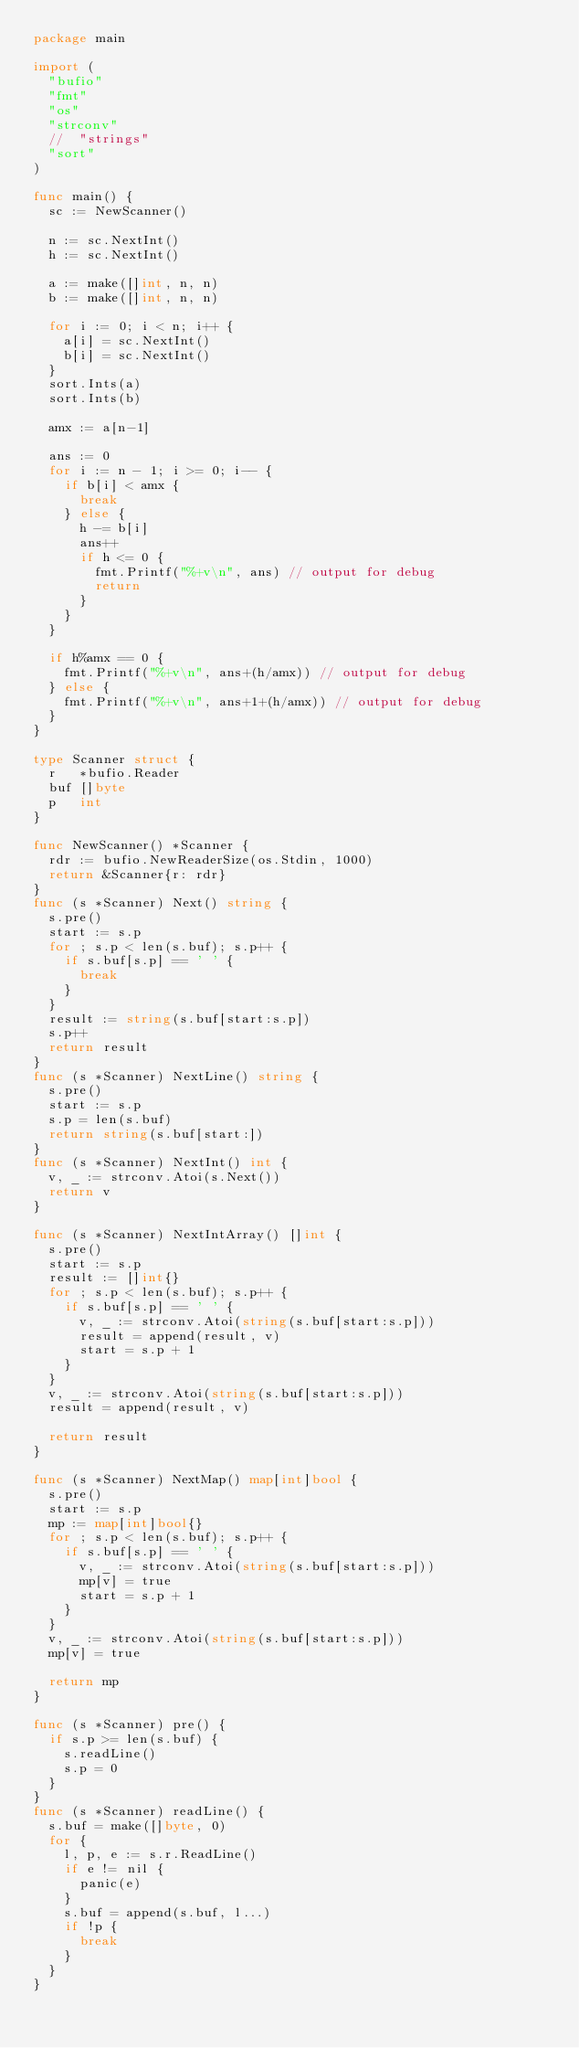Convert code to text. <code><loc_0><loc_0><loc_500><loc_500><_Go_>package main

import (
	"bufio"
	"fmt"
	"os"
	"strconv"
	//	"strings"
	"sort"
)

func main() {
	sc := NewScanner()

	n := sc.NextInt()
	h := sc.NextInt()

	a := make([]int, n, n)
	b := make([]int, n, n)

	for i := 0; i < n; i++ {
		a[i] = sc.NextInt()
		b[i] = sc.NextInt()
	}
	sort.Ints(a)
	sort.Ints(b)

	amx := a[n-1]

	ans := 0
	for i := n - 1; i >= 0; i-- {
		if b[i] < amx {
			break
		} else {
			h -= b[i]
			ans++
			if h <= 0 {
				fmt.Printf("%+v\n", ans) // output for debug
				return
			}
		}
	}

	if h%amx == 0 {
		fmt.Printf("%+v\n", ans+(h/amx)) // output for debug
	} else {
		fmt.Printf("%+v\n", ans+1+(h/amx)) // output for debug
	}
}

type Scanner struct {
	r   *bufio.Reader
	buf []byte
	p   int
}

func NewScanner() *Scanner {
	rdr := bufio.NewReaderSize(os.Stdin, 1000)
	return &Scanner{r: rdr}
}
func (s *Scanner) Next() string {
	s.pre()
	start := s.p
	for ; s.p < len(s.buf); s.p++ {
		if s.buf[s.p] == ' ' {
			break
		}
	}
	result := string(s.buf[start:s.p])
	s.p++
	return result
}
func (s *Scanner) NextLine() string {
	s.pre()
	start := s.p
	s.p = len(s.buf)
	return string(s.buf[start:])
}
func (s *Scanner) NextInt() int {
	v, _ := strconv.Atoi(s.Next())
	return v
}

func (s *Scanner) NextIntArray() []int {
	s.pre()
	start := s.p
	result := []int{}
	for ; s.p < len(s.buf); s.p++ {
		if s.buf[s.p] == ' ' {
			v, _ := strconv.Atoi(string(s.buf[start:s.p]))
			result = append(result, v)
			start = s.p + 1
		}
	}
	v, _ := strconv.Atoi(string(s.buf[start:s.p]))
	result = append(result, v)

	return result
}

func (s *Scanner) NextMap() map[int]bool {
	s.pre()
	start := s.p
	mp := map[int]bool{}
	for ; s.p < len(s.buf); s.p++ {
		if s.buf[s.p] == ' ' {
			v, _ := strconv.Atoi(string(s.buf[start:s.p]))
			mp[v] = true
			start = s.p + 1
		}
	}
	v, _ := strconv.Atoi(string(s.buf[start:s.p]))
	mp[v] = true

	return mp
}

func (s *Scanner) pre() {
	if s.p >= len(s.buf) {
		s.readLine()
		s.p = 0
	}
}
func (s *Scanner) readLine() {
	s.buf = make([]byte, 0)
	for {
		l, p, e := s.r.ReadLine()
		if e != nil {
			panic(e)
		}
		s.buf = append(s.buf, l...)
		if !p {
			break
		}
	}
}
</code> 